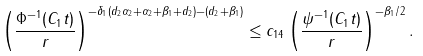Convert formula to latex. <formula><loc_0><loc_0><loc_500><loc_500>\left ( \frac { \Phi ^ { - 1 } ( C _ { 1 } t ) } { r } \right ) ^ { - \delta _ { 1 } ( d _ { 2 } \alpha _ { 2 } + \alpha _ { 2 } + \beta _ { 1 } + d _ { 2 } ) - ( d _ { 2 } + \beta _ { 1 } ) } \leq c _ { 1 4 } \left ( \frac { \psi ^ { - 1 } ( C _ { 1 } t ) } { r } \right ) ^ { - \beta _ { 1 } / 2 } .</formula> 